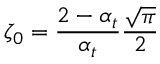<formula> <loc_0><loc_0><loc_500><loc_500>\zeta _ { 0 } = \frac { 2 - \alpha _ { t } } { \alpha _ { t } } \frac { \sqrt { \pi } } { 2 }</formula> 